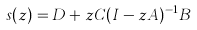Convert formula to latex. <formula><loc_0><loc_0><loc_500><loc_500>s ( z ) = D + z C ( I - z A ) ^ { - 1 } B</formula> 